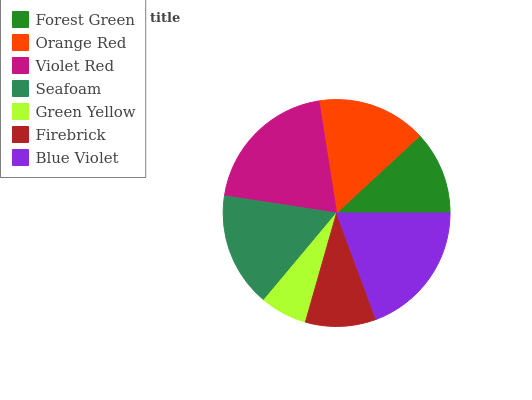Is Green Yellow the minimum?
Answer yes or no. Yes. Is Violet Red the maximum?
Answer yes or no. Yes. Is Orange Red the minimum?
Answer yes or no. No. Is Orange Red the maximum?
Answer yes or no. No. Is Orange Red greater than Forest Green?
Answer yes or no. Yes. Is Forest Green less than Orange Red?
Answer yes or no. Yes. Is Forest Green greater than Orange Red?
Answer yes or no. No. Is Orange Red less than Forest Green?
Answer yes or no. No. Is Orange Red the high median?
Answer yes or no. Yes. Is Orange Red the low median?
Answer yes or no. Yes. Is Blue Violet the high median?
Answer yes or no. No. Is Blue Violet the low median?
Answer yes or no. No. 